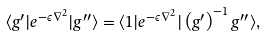<formula> <loc_0><loc_0><loc_500><loc_500>\langle g ^ { \prime } | e ^ { - \epsilon \nabla ^ { 2 } } | g ^ { \prime \prime } \rangle = \langle 1 | e ^ { - \epsilon \nabla ^ { 2 } } | \left ( g ^ { \prime } \right ) ^ { - 1 } g ^ { \prime \prime } \rangle ,</formula> 